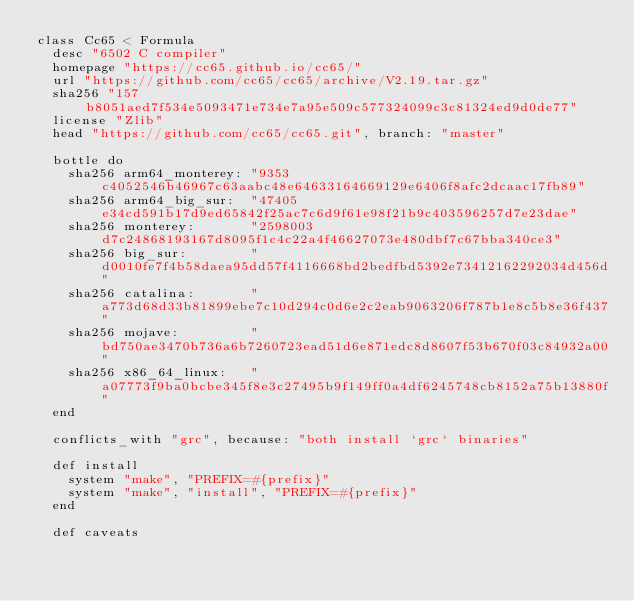<code> <loc_0><loc_0><loc_500><loc_500><_Ruby_>class Cc65 < Formula
  desc "6502 C compiler"
  homepage "https://cc65.github.io/cc65/"
  url "https://github.com/cc65/cc65/archive/V2.19.tar.gz"
  sha256 "157b8051aed7f534e5093471e734e7a95e509c577324099c3c81324ed9d0de77"
  license "Zlib"
  head "https://github.com/cc65/cc65.git", branch: "master"

  bottle do
    sha256 arm64_monterey: "9353c4052546b46967c63aabc48e64633164669129e6406f8afc2dcaac17fb89"
    sha256 arm64_big_sur:  "47405e34cd591b17d9ed65842f25ac7c6d9f61e98f21b9c403596257d7e23dae"
    sha256 monterey:       "2598003d7c24868193167d8095f1c4c22a4f46627073e480dbf7c67bba340ce3"
    sha256 big_sur:        "d0010fe7f4b58daea95dd57f4116668bd2bedfbd5392e73412162292034d456d"
    sha256 catalina:       "a773d68d33b81899ebe7c10d294c0d6e2c2eab9063206f787b1e8c5b8e36f437"
    sha256 mojave:         "bd750ae3470b736a6b7260723ead51d6e871edc8d8607f53b670f03c84932a00"
    sha256 x86_64_linux:   "a07773f9ba0bcbe345f8e3c27495b9f149ff0a4df6245748cb8152a75b13880f"
  end

  conflicts_with "grc", because: "both install `grc` binaries"

  def install
    system "make", "PREFIX=#{prefix}"
    system "make", "install", "PREFIX=#{prefix}"
  end

  def caveats</code> 